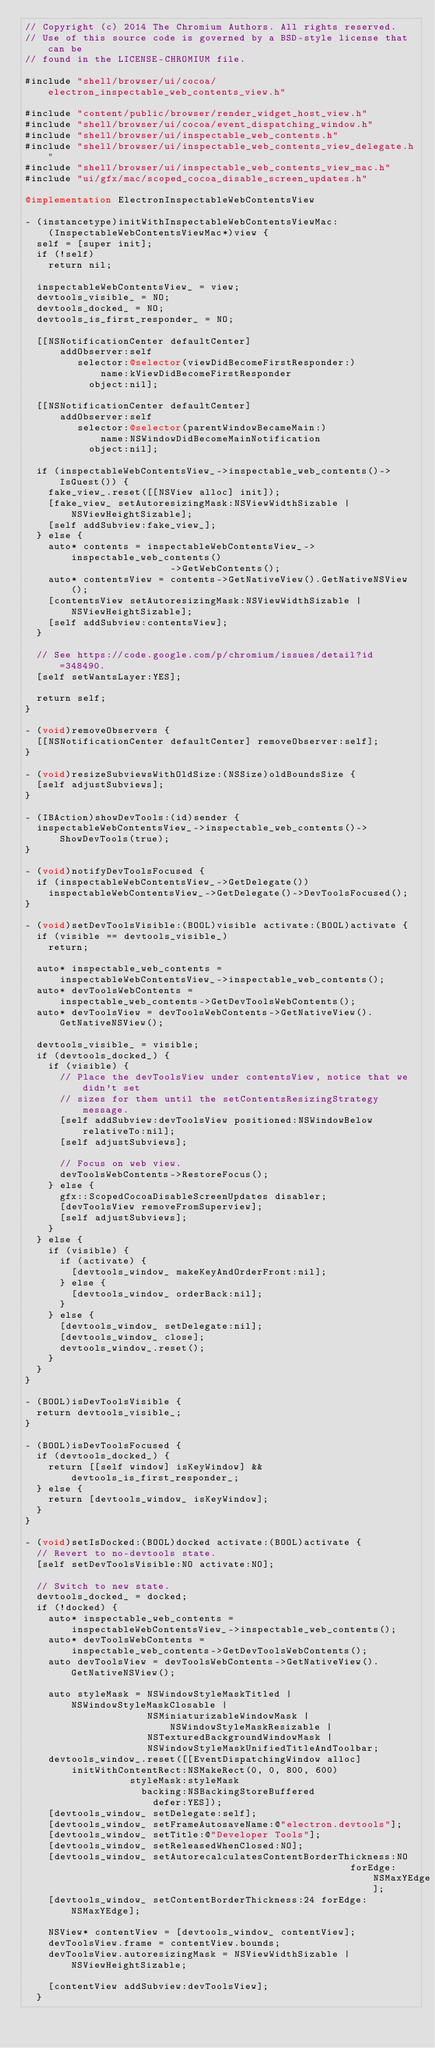<code> <loc_0><loc_0><loc_500><loc_500><_ObjectiveC_>// Copyright (c) 2014 The Chromium Authors. All rights reserved.
// Use of this source code is governed by a BSD-style license that can be
// found in the LICENSE-CHROMIUM file.

#include "shell/browser/ui/cocoa/electron_inspectable_web_contents_view.h"

#include "content/public/browser/render_widget_host_view.h"
#include "shell/browser/ui/cocoa/event_dispatching_window.h"
#include "shell/browser/ui/inspectable_web_contents.h"
#include "shell/browser/ui/inspectable_web_contents_view_delegate.h"
#include "shell/browser/ui/inspectable_web_contents_view_mac.h"
#include "ui/gfx/mac/scoped_cocoa_disable_screen_updates.h"

@implementation ElectronInspectableWebContentsView

- (instancetype)initWithInspectableWebContentsViewMac:
    (InspectableWebContentsViewMac*)view {
  self = [super init];
  if (!self)
    return nil;

  inspectableWebContentsView_ = view;
  devtools_visible_ = NO;
  devtools_docked_ = NO;
  devtools_is_first_responder_ = NO;

  [[NSNotificationCenter defaultCenter]
      addObserver:self
         selector:@selector(viewDidBecomeFirstResponder:)
             name:kViewDidBecomeFirstResponder
           object:nil];

  [[NSNotificationCenter defaultCenter]
      addObserver:self
         selector:@selector(parentWindowBecameMain:)
             name:NSWindowDidBecomeMainNotification
           object:nil];

  if (inspectableWebContentsView_->inspectable_web_contents()->IsGuest()) {
    fake_view_.reset([[NSView alloc] init]);
    [fake_view_ setAutoresizingMask:NSViewWidthSizable | NSViewHeightSizable];
    [self addSubview:fake_view_];
  } else {
    auto* contents = inspectableWebContentsView_->inspectable_web_contents()
                         ->GetWebContents();
    auto* contentsView = contents->GetNativeView().GetNativeNSView();
    [contentsView setAutoresizingMask:NSViewWidthSizable | NSViewHeightSizable];
    [self addSubview:contentsView];
  }

  // See https://code.google.com/p/chromium/issues/detail?id=348490.
  [self setWantsLayer:YES];

  return self;
}

- (void)removeObservers {
  [[NSNotificationCenter defaultCenter] removeObserver:self];
}

- (void)resizeSubviewsWithOldSize:(NSSize)oldBoundsSize {
  [self adjustSubviews];
}

- (IBAction)showDevTools:(id)sender {
  inspectableWebContentsView_->inspectable_web_contents()->ShowDevTools(true);
}

- (void)notifyDevToolsFocused {
  if (inspectableWebContentsView_->GetDelegate())
    inspectableWebContentsView_->GetDelegate()->DevToolsFocused();
}

- (void)setDevToolsVisible:(BOOL)visible activate:(BOOL)activate {
  if (visible == devtools_visible_)
    return;

  auto* inspectable_web_contents =
      inspectableWebContentsView_->inspectable_web_contents();
  auto* devToolsWebContents =
      inspectable_web_contents->GetDevToolsWebContents();
  auto* devToolsView = devToolsWebContents->GetNativeView().GetNativeNSView();

  devtools_visible_ = visible;
  if (devtools_docked_) {
    if (visible) {
      // Place the devToolsView under contentsView, notice that we didn't set
      // sizes for them until the setContentsResizingStrategy message.
      [self addSubview:devToolsView positioned:NSWindowBelow relativeTo:nil];
      [self adjustSubviews];

      // Focus on web view.
      devToolsWebContents->RestoreFocus();
    } else {
      gfx::ScopedCocoaDisableScreenUpdates disabler;
      [devToolsView removeFromSuperview];
      [self adjustSubviews];
    }
  } else {
    if (visible) {
      if (activate) {
        [devtools_window_ makeKeyAndOrderFront:nil];
      } else {
        [devtools_window_ orderBack:nil];
      }
    } else {
      [devtools_window_ setDelegate:nil];
      [devtools_window_ close];
      devtools_window_.reset();
    }
  }
}

- (BOOL)isDevToolsVisible {
  return devtools_visible_;
}

- (BOOL)isDevToolsFocused {
  if (devtools_docked_) {
    return [[self window] isKeyWindow] && devtools_is_first_responder_;
  } else {
    return [devtools_window_ isKeyWindow];
  }
}

- (void)setIsDocked:(BOOL)docked activate:(BOOL)activate {
  // Revert to no-devtools state.
  [self setDevToolsVisible:NO activate:NO];

  // Switch to new state.
  devtools_docked_ = docked;
  if (!docked) {
    auto* inspectable_web_contents =
        inspectableWebContentsView_->inspectable_web_contents();
    auto* devToolsWebContents =
        inspectable_web_contents->GetDevToolsWebContents();
    auto devToolsView = devToolsWebContents->GetNativeView().GetNativeNSView();

    auto styleMask = NSWindowStyleMaskTitled | NSWindowStyleMaskClosable |
                     NSMiniaturizableWindowMask | NSWindowStyleMaskResizable |
                     NSTexturedBackgroundWindowMask |
                     NSWindowStyleMaskUnifiedTitleAndToolbar;
    devtools_window_.reset([[EventDispatchingWindow alloc]
        initWithContentRect:NSMakeRect(0, 0, 800, 600)
                  styleMask:styleMask
                    backing:NSBackingStoreBuffered
                      defer:YES]);
    [devtools_window_ setDelegate:self];
    [devtools_window_ setFrameAutosaveName:@"electron.devtools"];
    [devtools_window_ setTitle:@"Developer Tools"];
    [devtools_window_ setReleasedWhenClosed:NO];
    [devtools_window_ setAutorecalculatesContentBorderThickness:NO
                                                        forEdge:NSMaxYEdge];
    [devtools_window_ setContentBorderThickness:24 forEdge:NSMaxYEdge];

    NSView* contentView = [devtools_window_ contentView];
    devToolsView.frame = contentView.bounds;
    devToolsView.autoresizingMask = NSViewWidthSizable | NSViewHeightSizable;

    [contentView addSubview:devToolsView];
  }</code> 